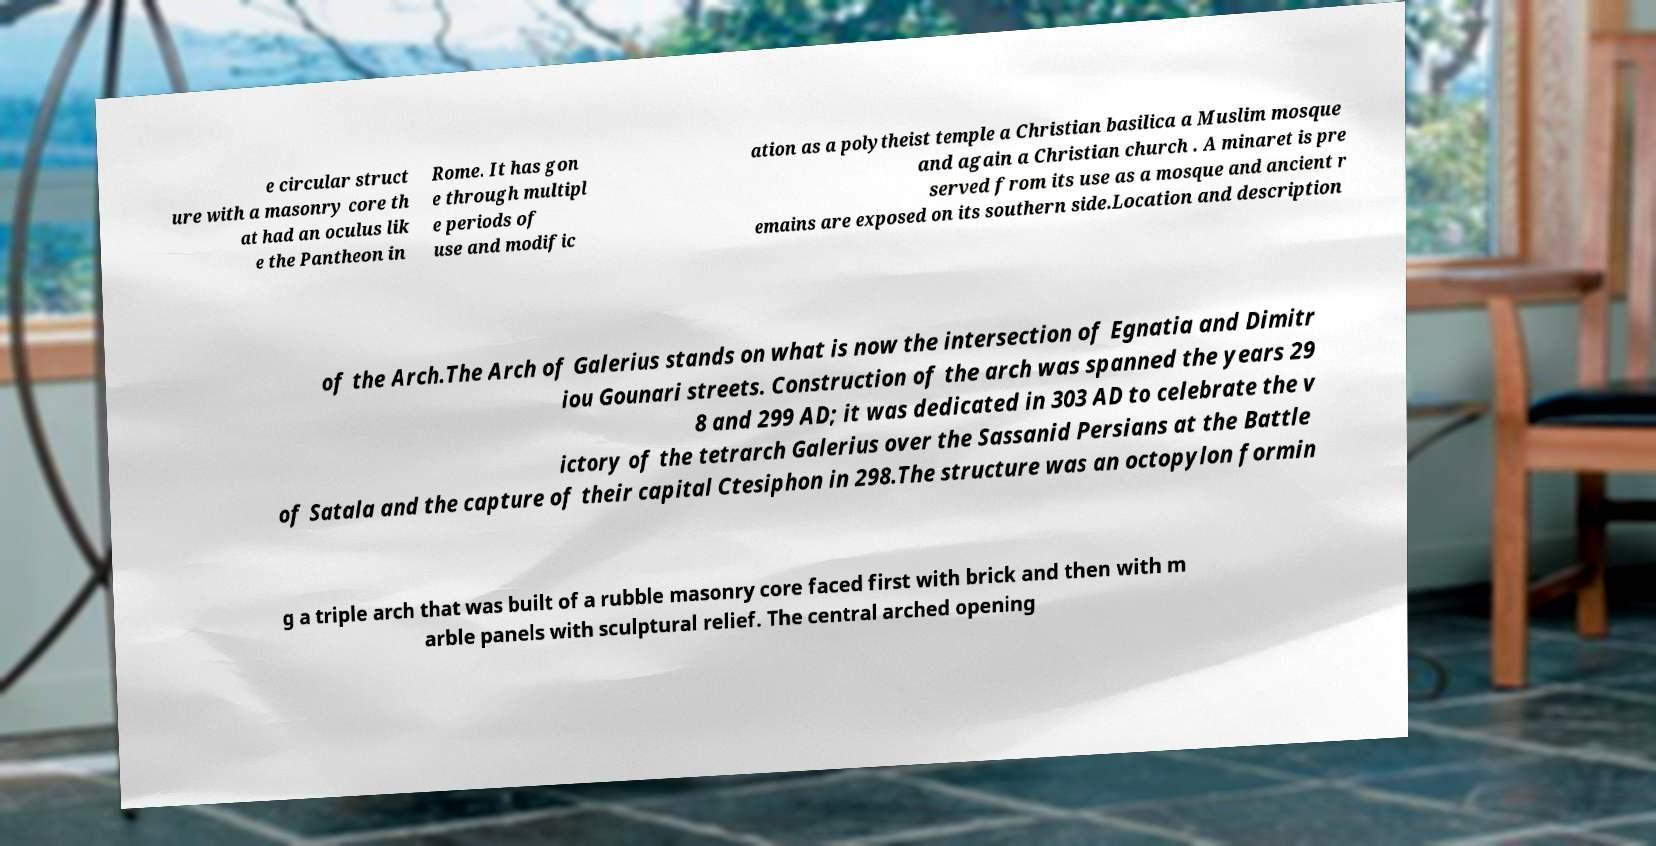Could you extract and type out the text from this image? e circular struct ure with a masonry core th at had an oculus lik e the Pantheon in Rome. It has gon e through multipl e periods of use and modific ation as a polytheist temple a Christian basilica a Muslim mosque and again a Christian church . A minaret is pre served from its use as a mosque and ancient r emains are exposed on its southern side.Location and description of the Arch.The Arch of Galerius stands on what is now the intersection of Egnatia and Dimitr iou Gounari streets. Construction of the arch was spanned the years 29 8 and 299 AD; it was dedicated in 303 AD to celebrate the v ictory of the tetrarch Galerius over the Sassanid Persians at the Battle of Satala and the capture of their capital Ctesiphon in 298.The structure was an octopylon formin g a triple arch that was built of a rubble masonry core faced first with brick and then with m arble panels with sculptural relief. The central arched opening 